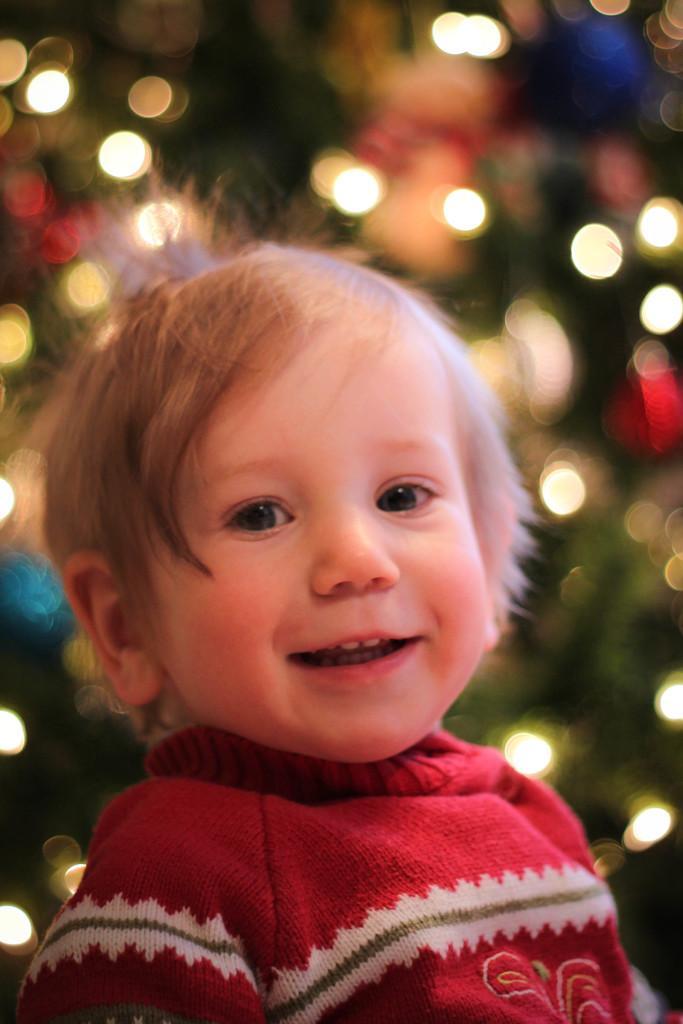Can you describe this image briefly? In the picture we can see face of a kid who is wearing red color dress and in the background image is blur. 